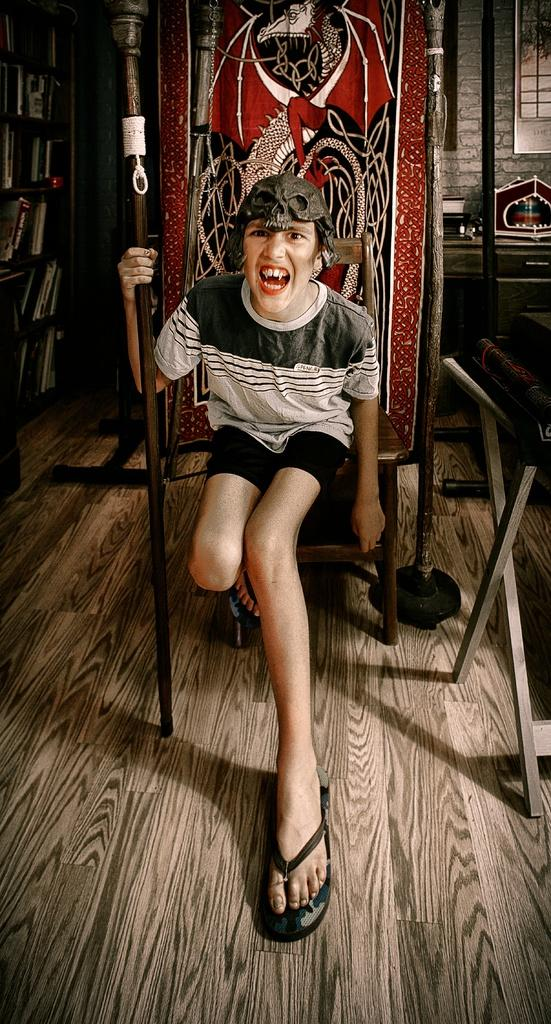What is the person in the image doing? There is a person sitting on a chair in the image. What is visible behind the chair in the image? There is a wall visible behind the chair in the image. What type of curtain is hanging from the person's chin in the image? There is no curtain or chin visible in the image; it only features a person sitting on a chair with a wall visible behind the chair. 